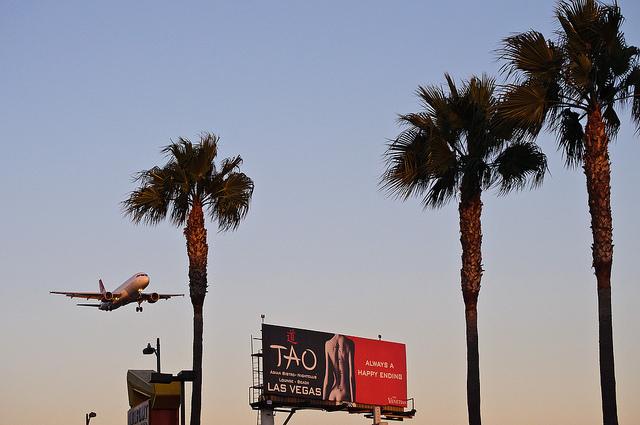Are there kites in the image?
Answer briefly. No. What logo is on the sign?
Be succinct. Tao. Is this an El train?
Be succinct. No. What is the tallest object on the right called?
Write a very short answer. Palm tree. Is this in America?
Answer briefly. Yes. How many types of equipment that utilize wind are featured in the picture?
Be succinct. 1. Are there people in the photo?
Give a very brief answer. No. How many palm trees do you see?
Short answer required. 3. What type of plant is in the background (green)?
Give a very brief answer. Palm tree. How many boards are there?
Answer briefly. 1. What does it say on the bottom of the board?
Short answer required. Las vegas. What is the large flying object on the left?
Quick response, please. Plane. What color is the sign's writing?
Keep it brief. White. Is the plane landing?
Give a very brief answer. Yes. In what city is this sign?
Write a very short answer. Las vegas. 